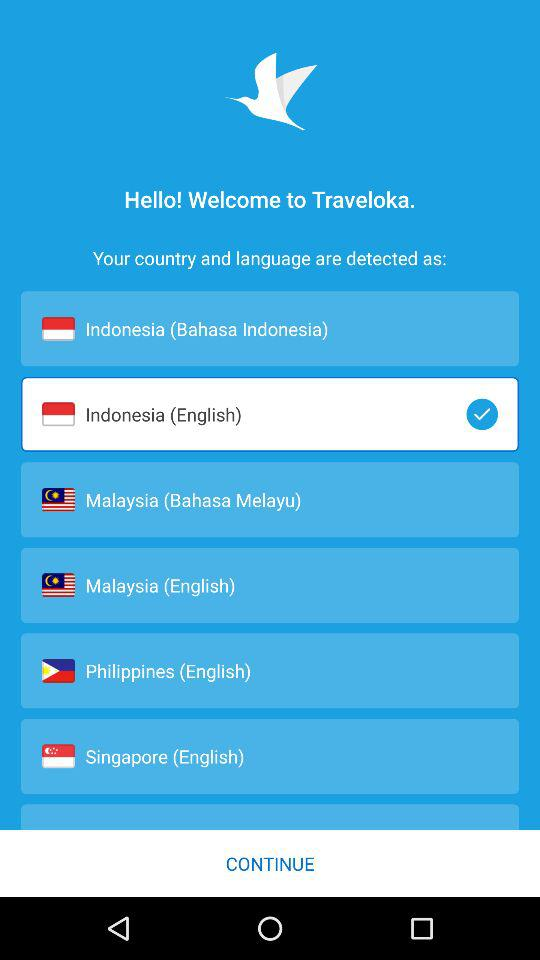Which country is selected? The selected country is Indonesia. 